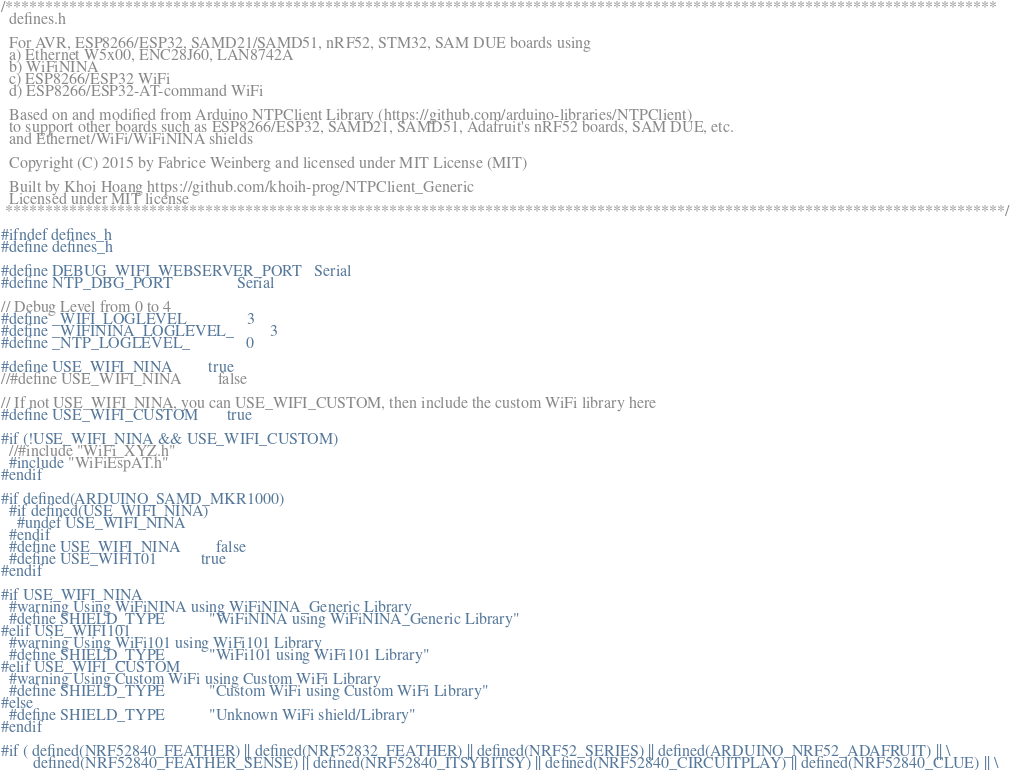<code> <loc_0><loc_0><loc_500><loc_500><_C_>/****************************************************************************************************************************
  defines.h

  For AVR, ESP8266/ESP32, SAMD21/SAMD51, nRF52, STM32, SAM DUE boards using 
  a) Ethernet W5x00, ENC28J60, LAN8742A
  b) WiFiNINA
  c) ESP8266/ESP32 WiFi
  d) ESP8266/ESP32-AT-command WiFi

  Based on and modified from Arduino NTPClient Library (https://github.com/arduino-libraries/NTPClient)
  to support other boards such as ESP8266/ESP32, SAMD21, SAMD51, Adafruit's nRF52 boards, SAM DUE, etc.
  and Ethernet/WiFi/WiFiNINA shields
  
  Copyright (C) 2015 by Fabrice Weinberg and licensed under MIT License (MIT)

  Built by Khoi Hoang https://github.com/khoih-prog/NTPClient_Generic
  Licensed under MIT license
 *****************************************************************************************************************************/

#ifndef defines_h
#define defines_h

#define DEBUG_WIFI_WEBSERVER_PORT   Serial
#define NTP_DBG_PORT                Serial

// Debug Level from 0 to 4
#define _WIFI_LOGLEVEL_             3
#define _WIFININA_LOGLEVEL_         3
#define _NTP_LOGLEVEL_              0

#define USE_WIFI_NINA         true
//#define USE_WIFI_NINA         false

// If not USE_WIFI_NINA, you can USE_WIFI_CUSTOM, then include the custom WiFi library here 
#define USE_WIFI_CUSTOM       true

#if (!USE_WIFI_NINA && USE_WIFI_CUSTOM)
  //#include "WiFi_XYZ.h"
  #include "WiFiEspAT.h"
#endif

#if defined(ARDUINO_SAMD_MKR1000)
  #if defined(USE_WIFI_NINA)
    #undef USE_WIFI_NINA
  #endif
  #define USE_WIFI_NINA         false
  #define USE_WIFI101           true
#endif

#if USE_WIFI_NINA
  #warning Using WiFiNINA using WiFiNINA_Generic Library
  #define SHIELD_TYPE           "WiFiNINA using WiFiNINA_Generic Library"
#elif USE_WIFI101
  #warning Using WiFi101 using WiFi101 Library
  #define SHIELD_TYPE           "WiFi101 using WiFi101 Library"
#elif USE_WIFI_CUSTOM
  #warning Using Custom WiFi using Custom WiFi Library
  #define SHIELD_TYPE           "Custom WiFi using Custom WiFi Library"
#else
  #define SHIELD_TYPE           "Unknown WiFi shield/Library" 
#endif

#if ( defined(NRF52840_FEATHER) || defined(NRF52832_FEATHER) || defined(NRF52_SERIES) || defined(ARDUINO_NRF52_ADAFRUIT) || \
        defined(NRF52840_FEATHER_SENSE) || defined(NRF52840_ITSYBITSY) || defined(NRF52840_CIRCUITPLAY) || defined(NRF52840_CLUE) || \</code> 